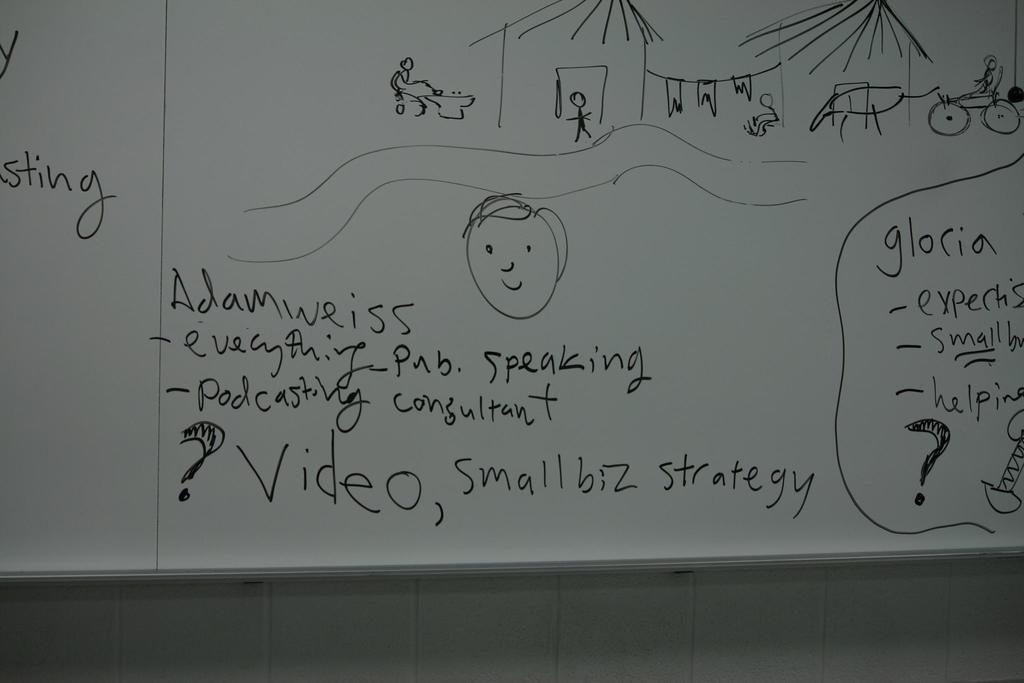<image>
Offer a succinct explanation of the picture presented. White board with a drawing and a small strategy 